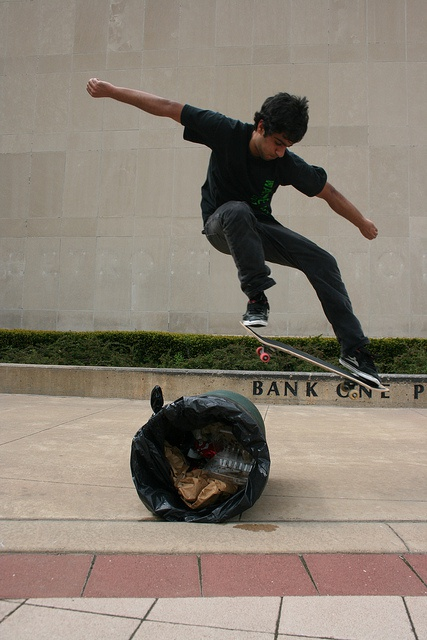Describe the objects in this image and their specific colors. I can see people in gray, black, darkgray, and maroon tones and skateboard in gray, black, and darkgray tones in this image. 